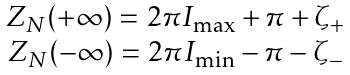Convert formula to latex. <formula><loc_0><loc_0><loc_500><loc_500>\begin{array} { c } { { Z _ { N } ( + \infty ) = 2 \pi I _ { \max } + \pi + \zeta _ { + } } } \\ { { Z _ { N } ( - \infty ) = 2 \pi I _ { \min } - \pi - \zeta _ { - } } } \end{array}</formula> 